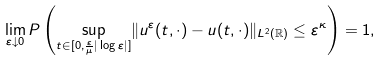<formula> <loc_0><loc_0><loc_500><loc_500>\lim _ { \varepsilon \downarrow 0 } P \left ( \underset { t \in [ 0 , \frac { \varepsilon } { \mu } | \log \varepsilon | ] } { \sup } \| u ^ { \varepsilon } ( t , \cdot ) - u ( t , \cdot ) \| _ { L ^ { 2 } ( \mathbb { R } ) } \leq \varepsilon ^ { \kappa } \right ) = 1 ,</formula> 